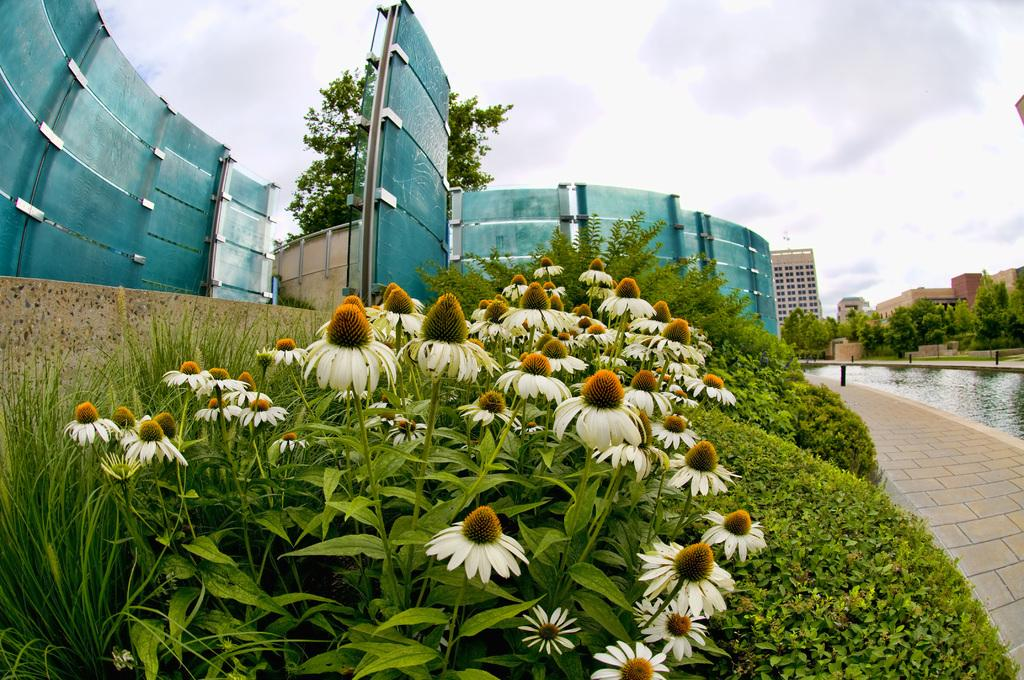What type of structures can be seen in the image? There are buildings in the image. What type of vegetation is present in the image? There are plants, flowers, and trees in the image. What natural element can be seen in the image? There is water visible in the image. What type of man-made objects can be seen in the image? There are poles and a wall in the image. What is visible in the background of the image? The sky is visible in the background of the image, with clouds present. Can you see a stove in the image? There is no stove present in the image. What type of smile can be seen on the flowers in the image? There are no smiles on the flowers in the image, as flowers do not have facial expressions. 